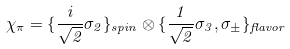Convert formula to latex. <formula><loc_0><loc_0><loc_500><loc_500>\chi _ { \pi } = \{ \frac { i } { \sqrt { 2 } } \sigma _ { 2 } \} _ { s p i n } \otimes \{ \frac { 1 } { \sqrt { 2 } } \sigma _ { 3 } , \sigma _ { \pm } \} _ { f l a v o r }</formula> 